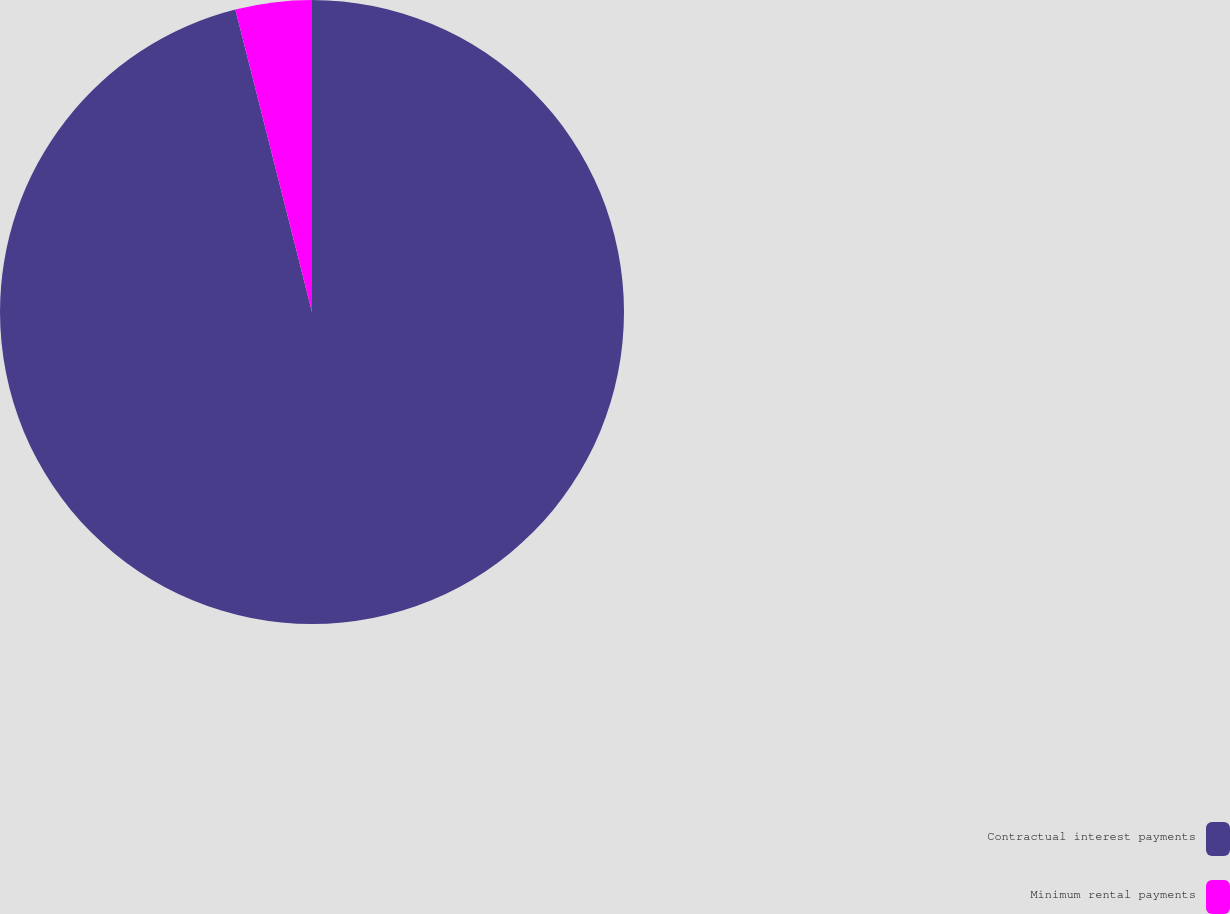<chart> <loc_0><loc_0><loc_500><loc_500><pie_chart><fcel>Contractual interest payments<fcel>Minimum rental payments<nl><fcel>96.05%<fcel>3.95%<nl></chart> 